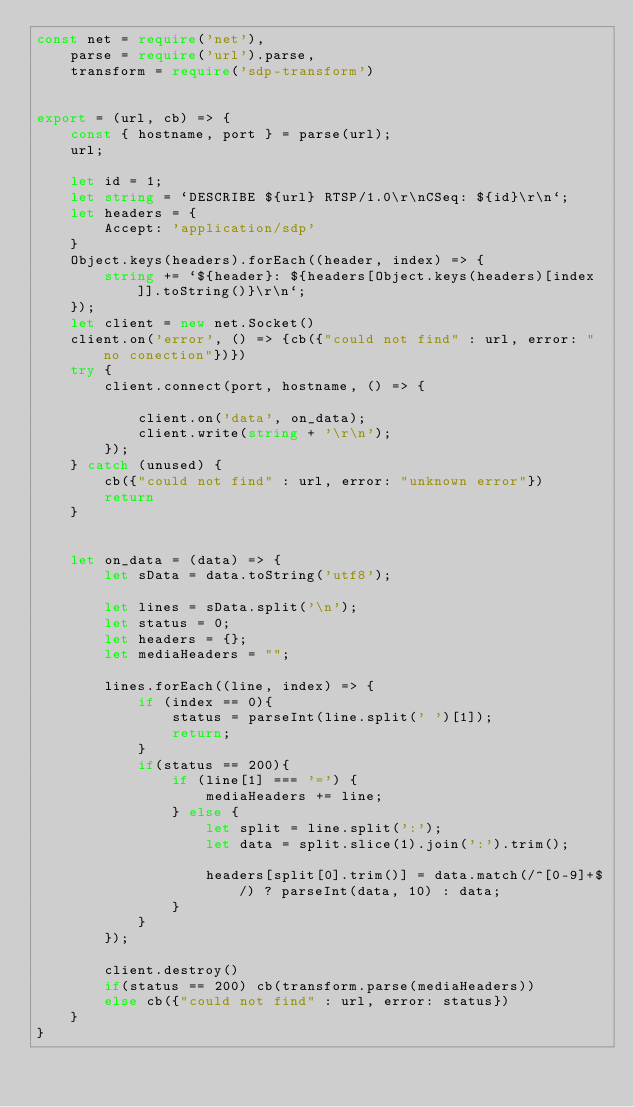<code> <loc_0><loc_0><loc_500><loc_500><_TypeScript_>const net = require('net'),
    parse = require('url').parse,
    transform = require('sdp-transform') 


export = (url, cb) => {
    const { hostname, port } = parse(url);
    url;

    let id = 1;
    let string = `DESCRIBE ${url} RTSP/1.0\r\nCSeq: ${id}\r\n`;
    let headers = {
        Accept: 'application/sdp'
    }
    Object.keys(headers).forEach((header, index) => {
        string += `${header}: ${headers[Object.keys(headers)[index]].toString()}\r\n`;
    });
    let client = new net.Socket()
    client.on('error', () => {cb({"could not find" : url, error: "no conection"})})
    try {
        client.connect(port, hostname, () => {

            client.on('data', on_data);
            client.write(string + '\r\n');
        });
    } catch (unused) {
        cb({"could not find" : url, error: "unknown error"})
        return
    }
    

    let on_data = (data) => {
        let sData = data.toString('utf8');

        let lines = sData.split('\n');
        let status = 0;
        let headers = {};
        let mediaHeaders = "";

        lines.forEach((line, index) => {
            if (index == 0){
                status = parseInt(line.split(' ')[1]);
                return;
            }
            if(status == 200){
                if (line[1] === '=') {
                    mediaHeaders += line;
                } else {
                    let split = line.split(':');
                    let data = split.slice(1).join(':').trim();

                    headers[split[0].trim()] = data.match(/^[0-9]+$/) ? parseInt(data, 10) : data;
                }
            }
        });

        client.destroy()
        if(status == 200) cb(transform.parse(mediaHeaders))
        else cb({"could not find" : url, error: status})
    }
}</code> 